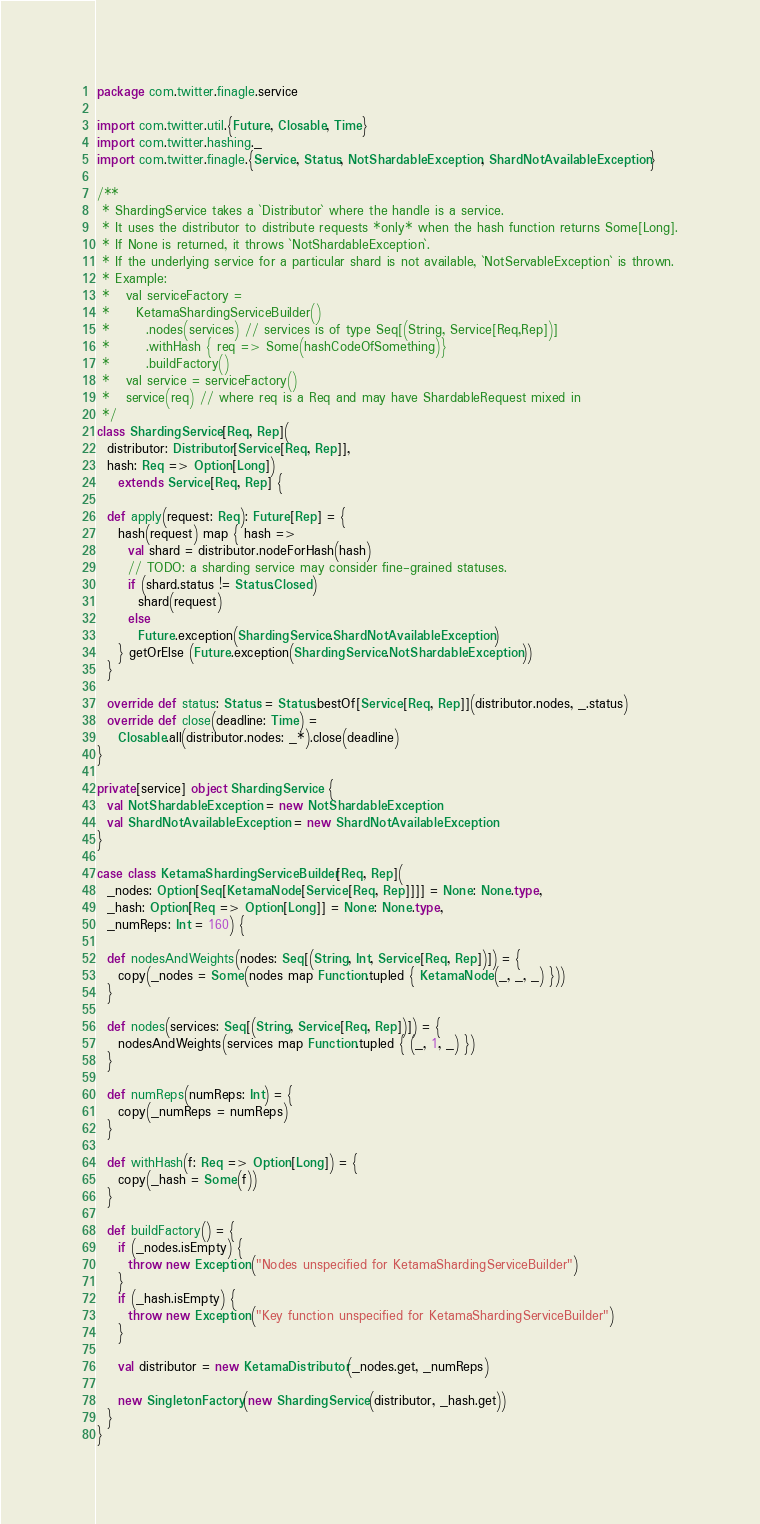Convert code to text. <code><loc_0><loc_0><loc_500><loc_500><_Scala_>package com.twitter.finagle.service

import com.twitter.util.{Future, Closable, Time}
import com.twitter.hashing._
import com.twitter.finagle.{Service, Status, NotShardableException, ShardNotAvailableException}

/**
 * ShardingService takes a `Distributor` where the handle is a service.
 * It uses the distributor to distribute requests *only* when the hash function returns Some[Long].
 * If None is returned, it throws `NotShardableException`.
 * If the underlying service for a particular shard is not available, `NotServableException` is thrown.
 * Example:
 *   val serviceFactory =
 *     KetamaShardingServiceBuilder()
 *       .nodes(services) // services is of type Seq[(String, Service[Req,Rep])]
 *       .withHash { req => Some(hashCodeOfSomething)}
 *       .buildFactory()
 *   val service = serviceFactory()
 *   service(req) // where req is a Req and may have ShardableRequest mixed in
 */
class ShardingService[Req, Rep](
  distributor: Distributor[Service[Req, Rep]],
  hash: Req => Option[Long])
    extends Service[Req, Rep] {

  def apply(request: Req): Future[Rep] = {
    hash(request) map { hash =>
      val shard = distributor.nodeForHash(hash)
      // TODO: a sharding service may consider fine-grained statuses.
      if (shard.status != Status.Closed)
        shard(request)
      else
        Future.exception(ShardingService.ShardNotAvailableException)
    } getOrElse (Future.exception(ShardingService.NotShardableException))
  }

  override def status: Status = Status.bestOf[Service[Req, Rep]](distributor.nodes, _.status)
  override def close(deadline: Time) =
    Closable.all(distributor.nodes: _*).close(deadline)
}

private[service] object ShardingService {
  val NotShardableException = new NotShardableException
  val ShardNotAvailableException = new ShardNotAvailableException
}

case class KetamaShardingServiceBuilder[Req, Rep](
  _nodes: Option[Seq[KetamaNode[Service[Req, Rep]]]] = None: None.type,
  _hash: Option[Req => Option[Long]] = None: None.type,
  _numReps: Int = 160) {

  def nodesAndWeights(nodes: Seq[(String, Int, Service[Req, Rep])]) = {
    copy(_nodes = Some(nodes map Function.tupled { KetamaNode(_, _, _) }))
  }

  def nodes(services: Seq[(String, Service[Req, Rep])]) = {
    nodesAndWeights(services map Function.tupled { (_, 1, _) })
  }

  def numReps(numReps: Int) = {
    copy(_numReps = numReps)
  }

  def withHash(f: Req => Option[Long]) = {
    copy(_hash = Some(f))
  }

  def buildFactory() = {
    if (_nodes.isEmpty) {
      throw new Exception("Nodes unspecified for KetamaShardingServiceBuilder")
    }
    if (_hash.isEmpty) {
      throw new Exception("Key function unspecified for KetamaShardingServiceBuilder")
    }

    val distributor = new KetamaDistributor(_nodes.get, _numReps)

    new SingletonFactory(new ShardingService(distributor, _hash.get))
  }
}
</code> 